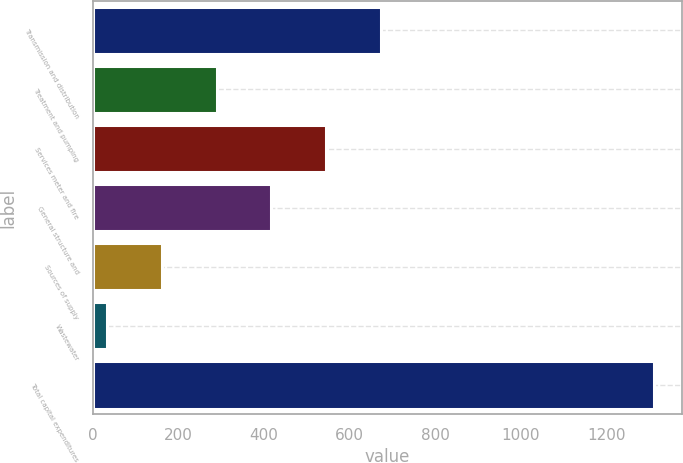Convert chart. <chart><loc_0><loc_0><loc_500><loc_500><bar_chart><fcel>Transmission and distribution<fcel>Treatment and pumping<fcel>Services meter and fire<fcel>General structure and<fcel>Sources of supply<fcel>Wastewater<fcel>Total capital expenditures<nl><fcel>672.5<fcel>289.4<fcel>544.8<fcel>417.1<fcel>161.7<fcel>34<fcel>1311<nl></chart> 